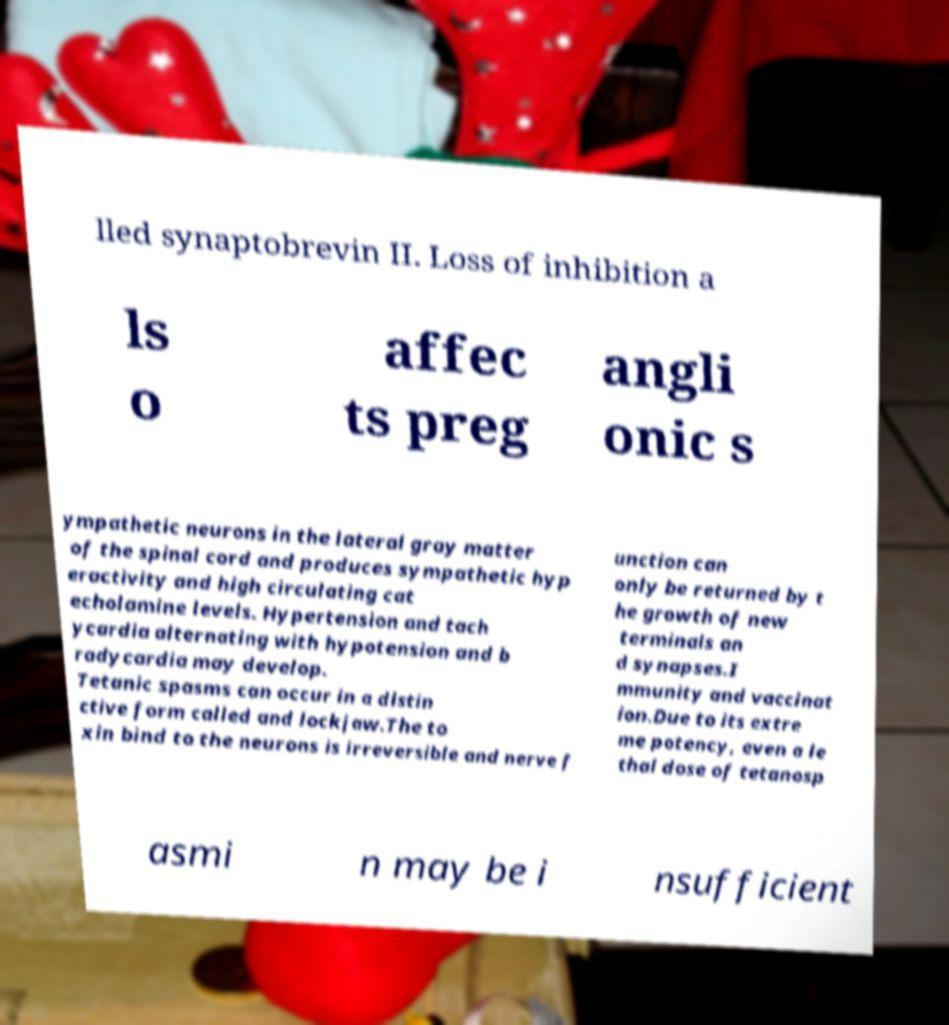Please identify and transcribe the text found in this image. lled synaptobrevin II. Loss of inhibition a ls o affec ts preg angli onic s ympathetic neurons in the lateral gray matter of the spinal cord and produces sympathetic hyp eractivity and high circulating cat echolamine levels. Hypertension and tach ycardia alternating with hypotension and b radycardia may develop. Tetanic spasms can occur in a distin ctive form called and lockjaw.The to xin bind to the neurons is irreversible and nerve f unction can only be returned by t he growth of new terminals an d synapses.I mmunity and vaccinat ion.Due to its extre me potency, even a le thal dose of tetanosp asmi n may be i nsufficient 